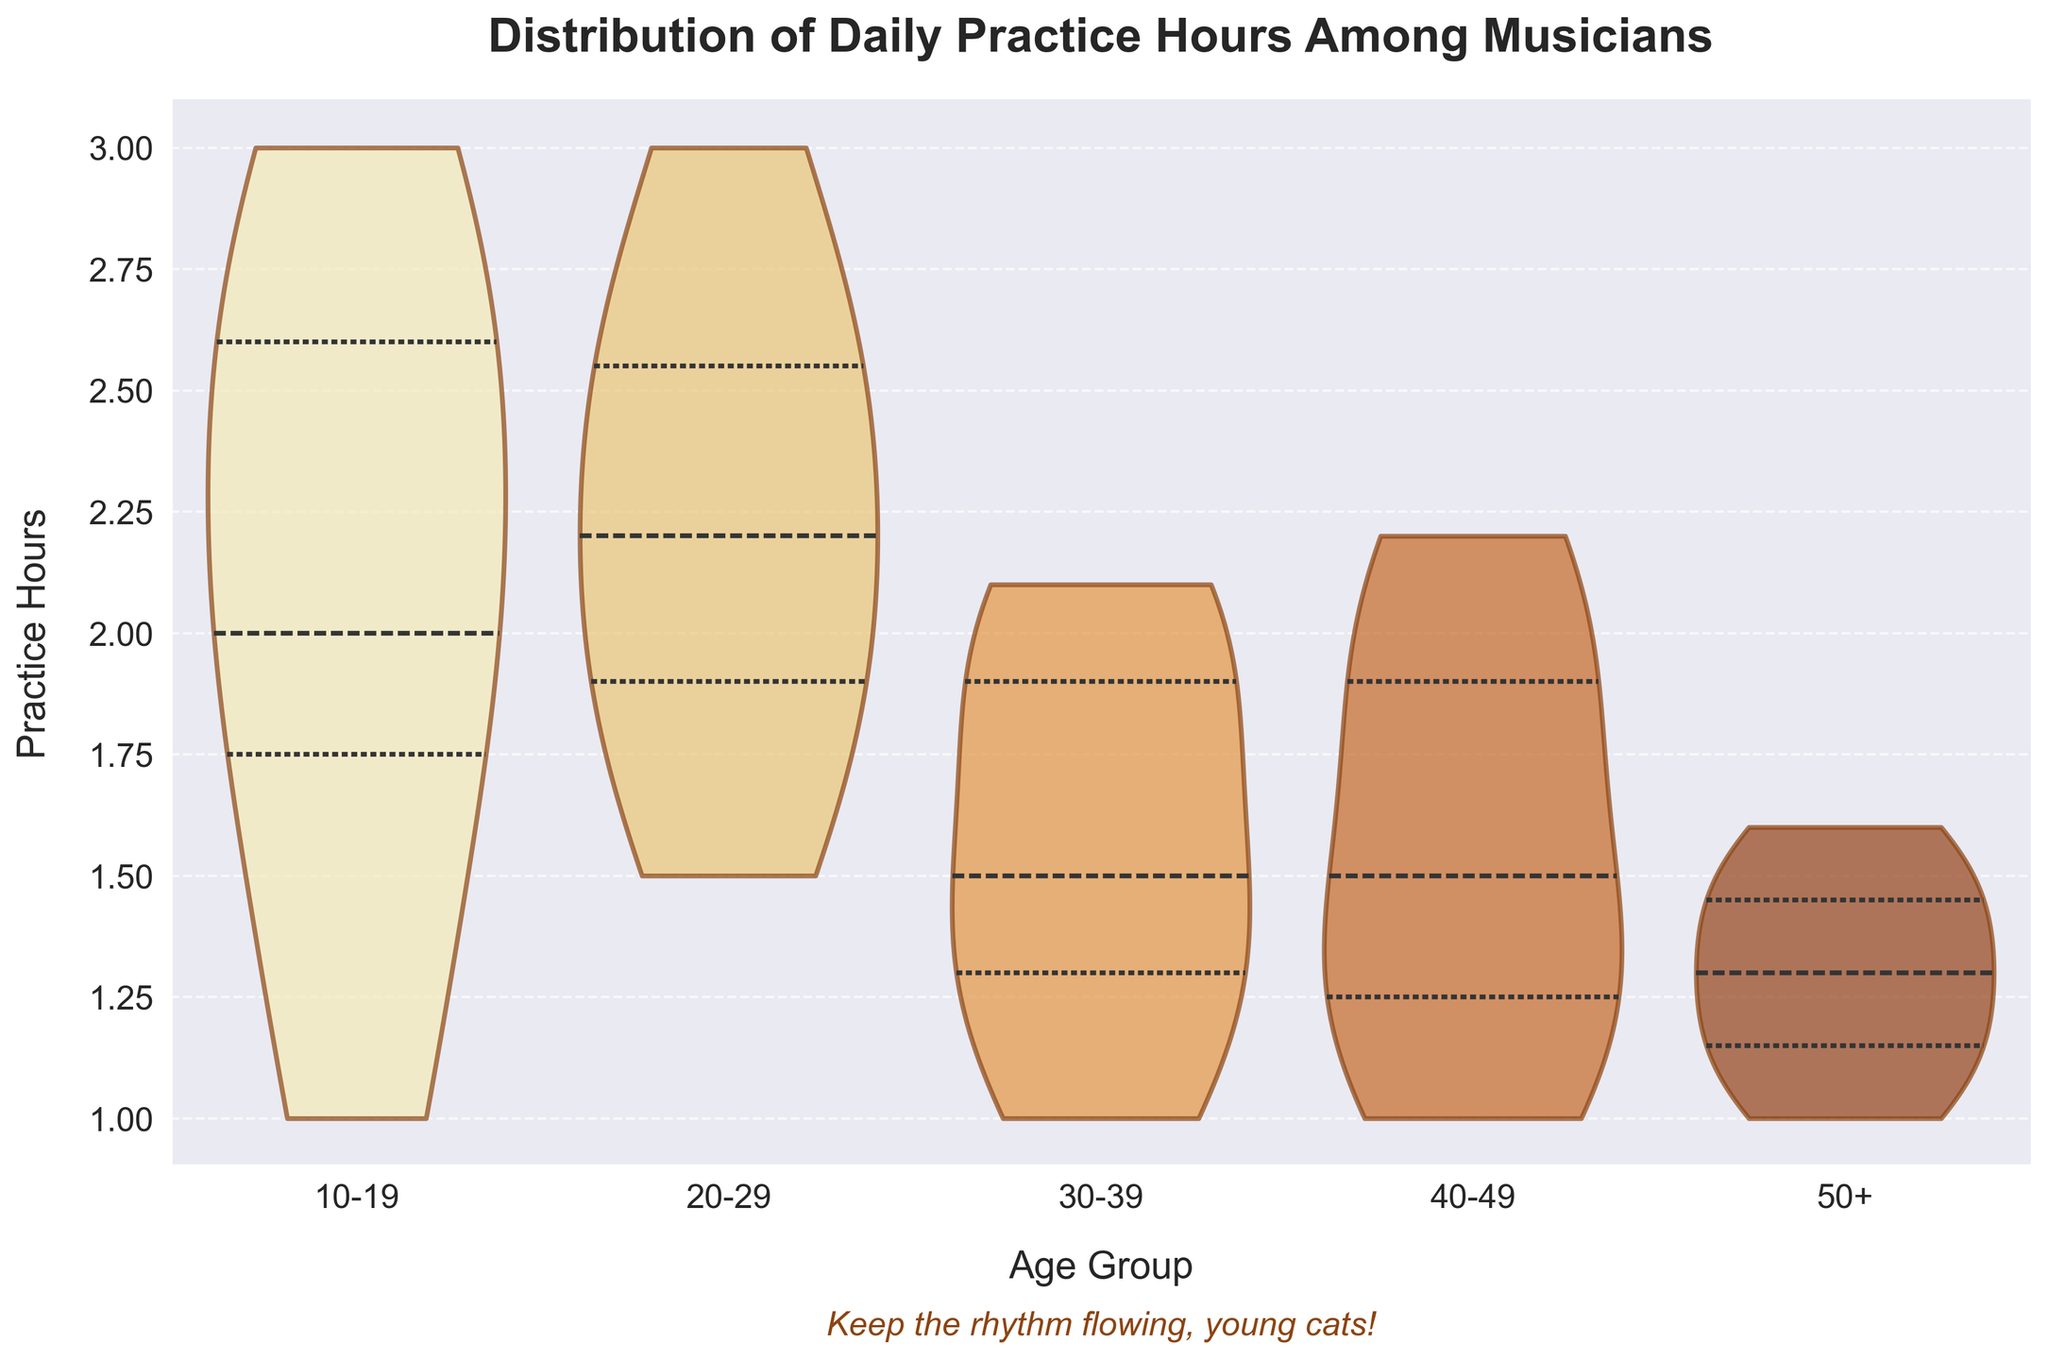What is the title of the figure? The title of the figure is displayed prominently at the top of the chart, indicating the subject of the visualized data.
Answer: Distribution of Daily Practice Hours Among Musicians What are the labels for the x and y axes? The x-axis label is located below the axis, and the y-axis label is positioned to the left of the y-axis.
Answer: The x-axis is labeled 'Age Group' and the y-axis is labeled 'Practice Hours' Which age group has the highest median practice hours? On a violin plot, the inner quartile lines show the median value. Look for the highest median line across the different age groups.
Answer: 10-19 Which age group shows the smallest variation in practice hours? Look for the narrowest "violin" shape among the age groups to identify the one with the smallest spread of practice hours.
Answer: 50+ What is the range of practice hours for the age group 20-29? Examine the "violin" for the 20-29 age group from its lowest to highest points to find the range of practice hours.
Answer: The range is 1.5 to 3 hours How do the practice hours of the 30-39 group compare to those of the 40-49 group? Compare the shapes and spread of the "violin" plots for these two age groups to determine their practice hour distributions.
Answer: The practice hours of the 30-39 group are slightly narrower and start at a lower point compared to the 40-49 group What central tendency measure is highlighted in the violin plot? The inner lines within each "violin" plot, typically a different color or thickness, indicate the central tendency measure highlighted.
Answer: Median Which age group has the highest upper quartile of practice hours? Look at the top edge of the inner quartile lines within the "violin" plots to find the highest upper quartile.
Answer: 10-19 How does the annotation within the chart reflect encouragement for younger musicians? Look for any text within the chart that provides motivational statements, typically located near the title or axes.
Answer: The text "Keep the rhythm flowing, young cats!" is present, encouraging younger musicians 